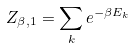Convert formula to latex. <formula><loc_0><loc_0><loc_500><loc_500>Z _ { \beta , 1 } = \sum _ { k } e ^ { - \beta E _ { k } }</formula> 